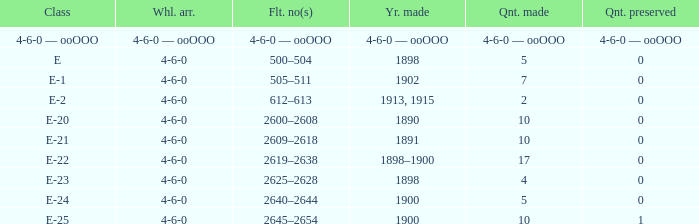What is the volume created of the e-22 class, which has a conserved volume of 0? 17.0. 